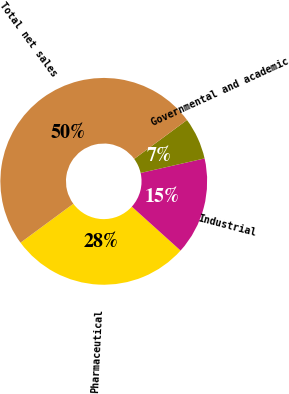Convert chart to OTSL. <chart><loc_0><loc_0><loc_500><loc_500><pie_chart><fcel>Pharmaceutical<fcel>Industrial<fcel>Governmental and academic<fcel>Total net sales<nl><fcel>28.22%<fcel>15.23%<fcel>6.55%<fcel>50.0%<nl></chart> 